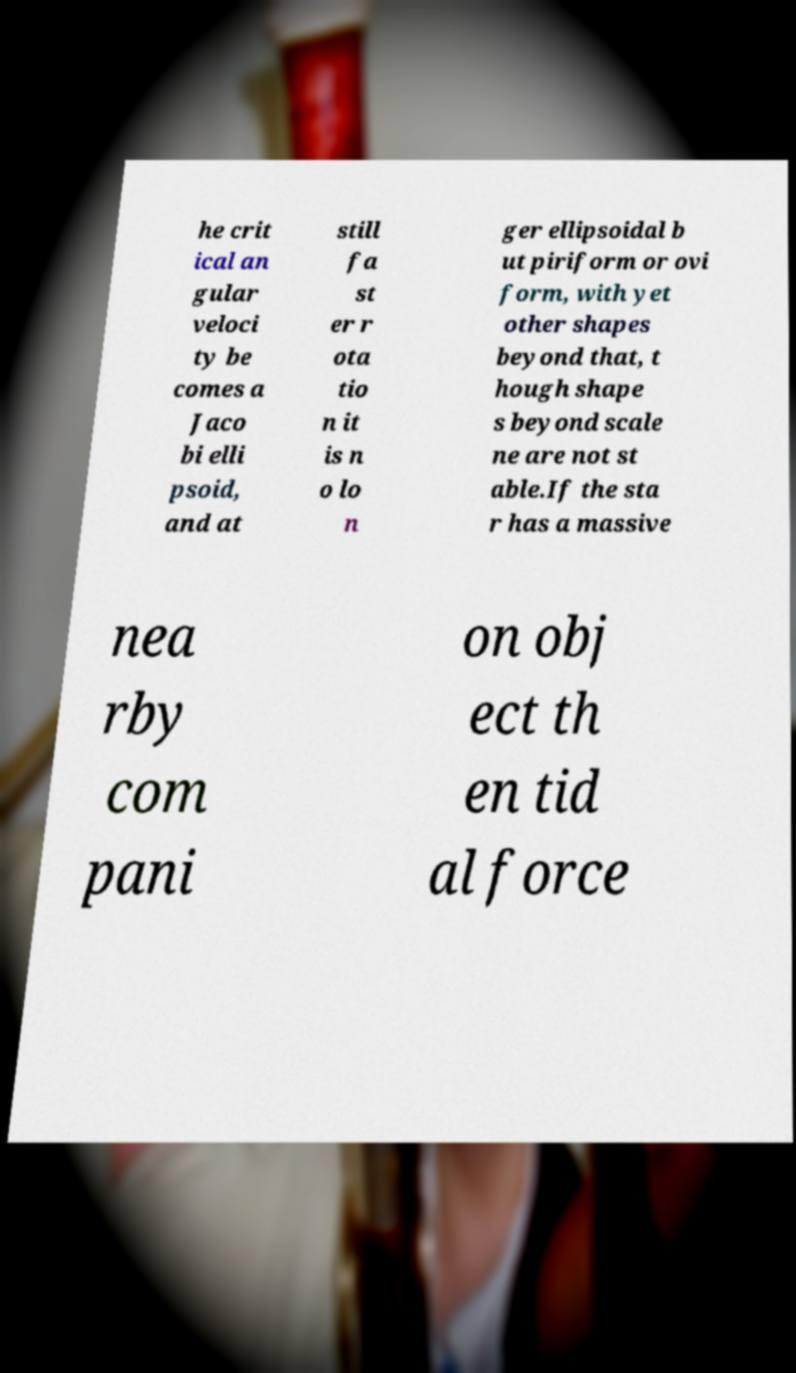Can you accurately transcribe the text from the provided image for me? he crit ical an gular veloci ty be comes a Jaco bi elli psoid, and at still fa st er r ota tio n it is n o lo n ger ellipsoidal b ut piriform or ovi form, with yet other shapes beyond that, t hough shape s beyond scale ne are not st able.If the sta r has a massive nea rby com pani on obj ect th en tid al force 